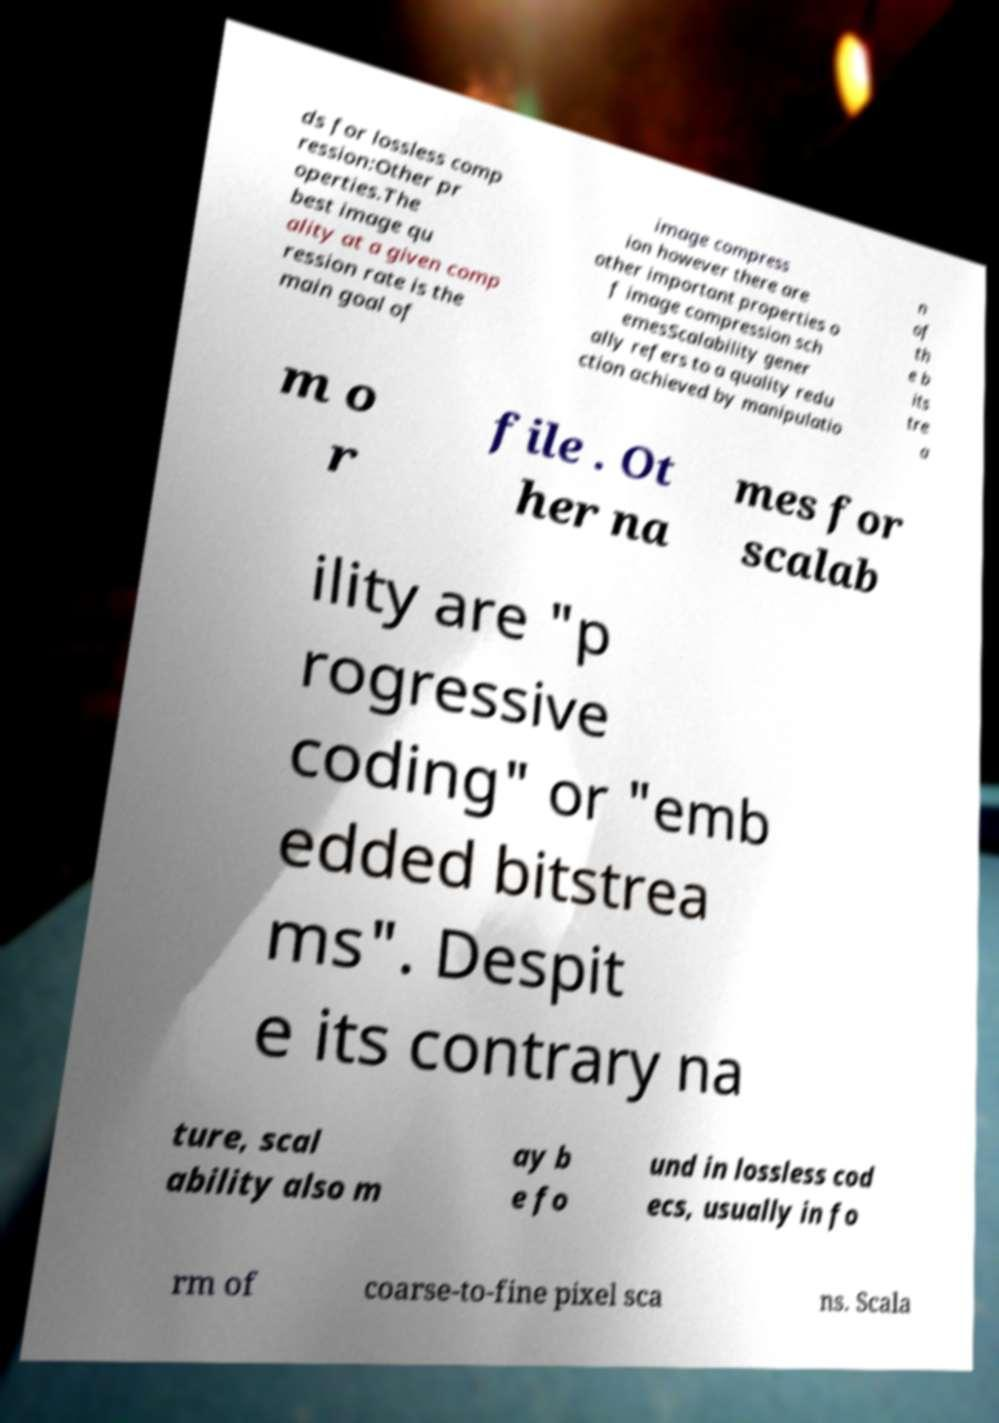I need the written content from this picture converted into text. Can you do that? ds for lossless comp ression:Other pr operties.The best image qu ality at a given comp ression rate is the main goal of image compress ion however there are other important properties o f image compression sch emesScalability gener ally refers to a quality redu ction achieved by manipulatio n of th e b its tre a m o r file . Ot her na mes for scalab ility are "p rogressive coding" or "emb edded bitstrea ms". Despit e its contrary na ture, scal ability also m ay b e fo und in lossless cod ecs, usually in fo rm of coarse-to-fine pixel sca ns. Scala 